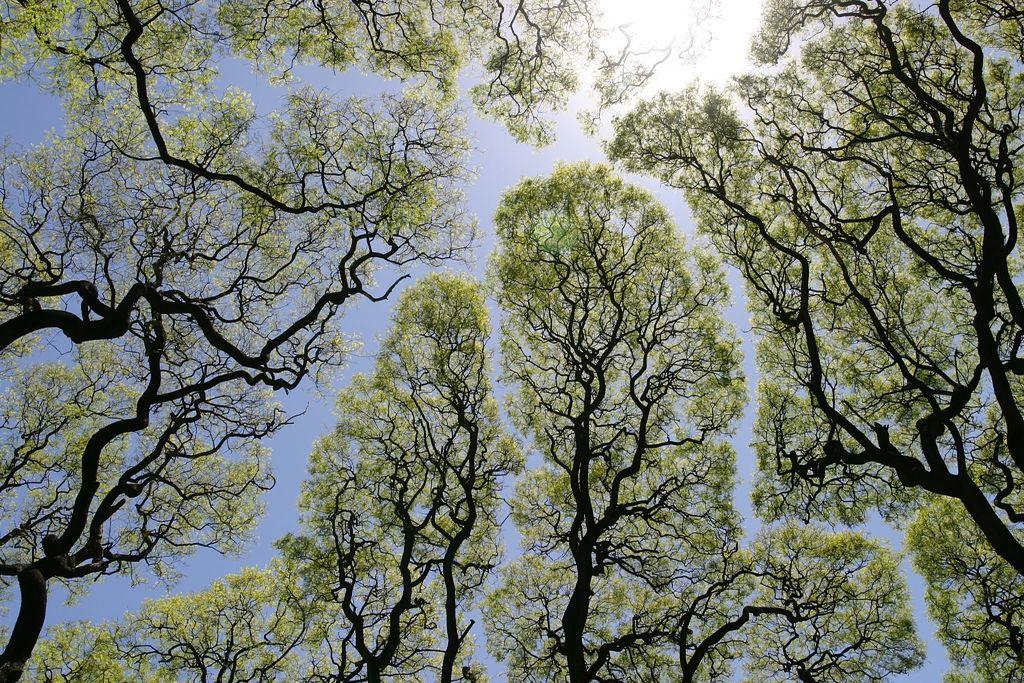What type of vegetation can be seen in the image? There are trees in the image. What pets are involved in a fight in the image? There are no pets or fights present in the image; it only features trees. 